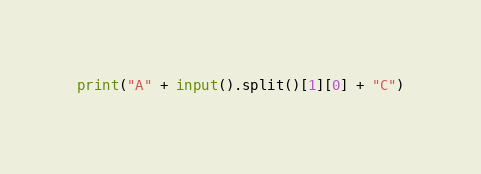<code> <loc_0><loc_0><loc_500><loc_500><_Python_>print("A" + input().split()[1][0] + "C")</code> 